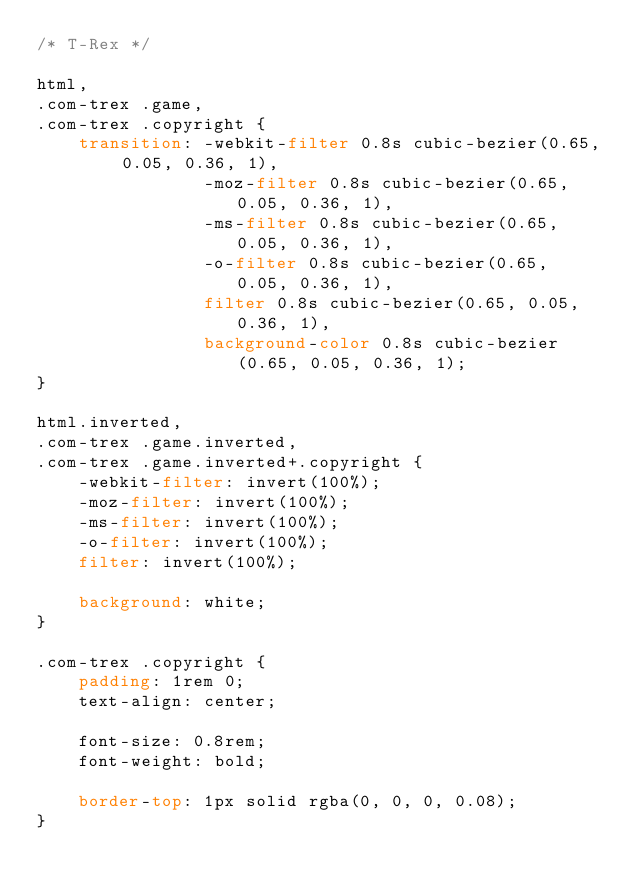<code> <loc_0><loc_0><loc_500><loc_500><_CSS_>/* T-Rex */

html,
.com-trex .game,
.com-trex .copyright {
	transition: -webkit-filter 0.8s cubic-bezier(0.65, 0.05, 0.36, 1),
				-moz-filter 0.8s cubic-bezier(0.65, 0.05, 0.36, 1),
				-ms-filter 0.8s cubic-bezier(0.65, 0.05, 0.36, 1),
				-o-filter 0.8s cubic-bezier(0.65, 0.05, 0.36, 1),
				filter 0.8s cubic-bezier(0.65, 0.05, 0.36, 1),
				background-color 0.8s cubic-bezier(0.65, 0.05, 0.36, 1);
}

html.inverted,
.com-trex .game.inverted,
.com-trex .game.inverted+.copyright {
	-webkit-filter: invert(100%);
	-moz-filter: invert(100%);
	-ms-filter: invert(100%);
	-o-filter: invert(100%);
	filter: invert(100%);

	background: white;
}

.com-trex .copyright {
	padding: 1rem 0;
	text-align: center;

	font-size: 0.8rem;
	font-weight: bold;

	border-top: 1px solid rgba(0, 0, 0, 0.08);
}
</code> 